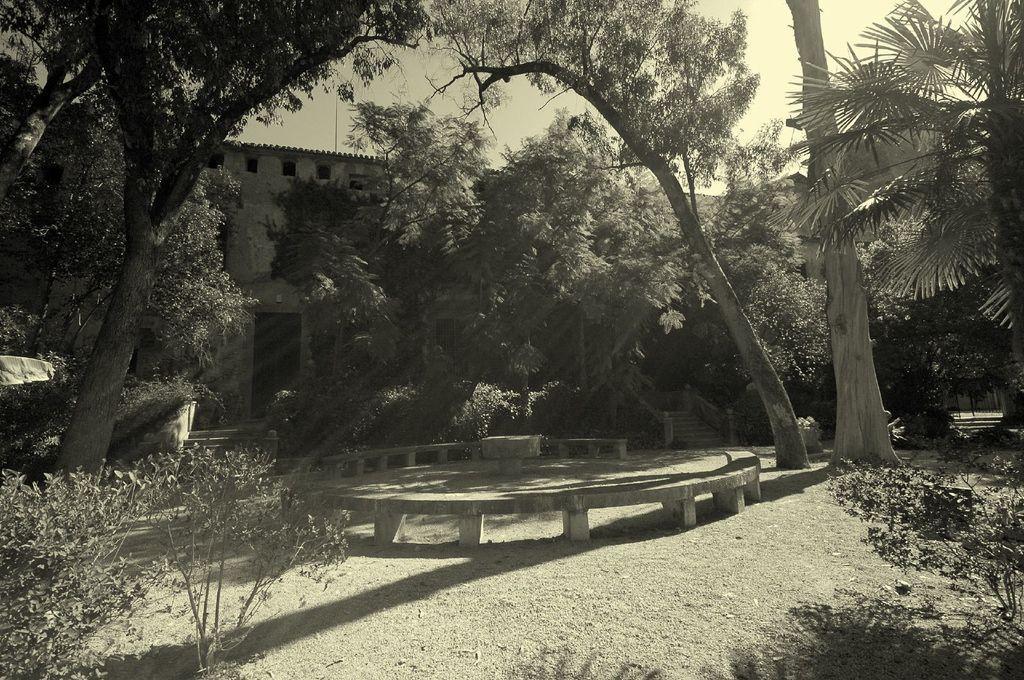Please provide a concise description of this image. In this image we can see trees on the left side and the right side as well. Here we can see the wooden bench. In the background, we can see the building. Here we can see the staircase. 